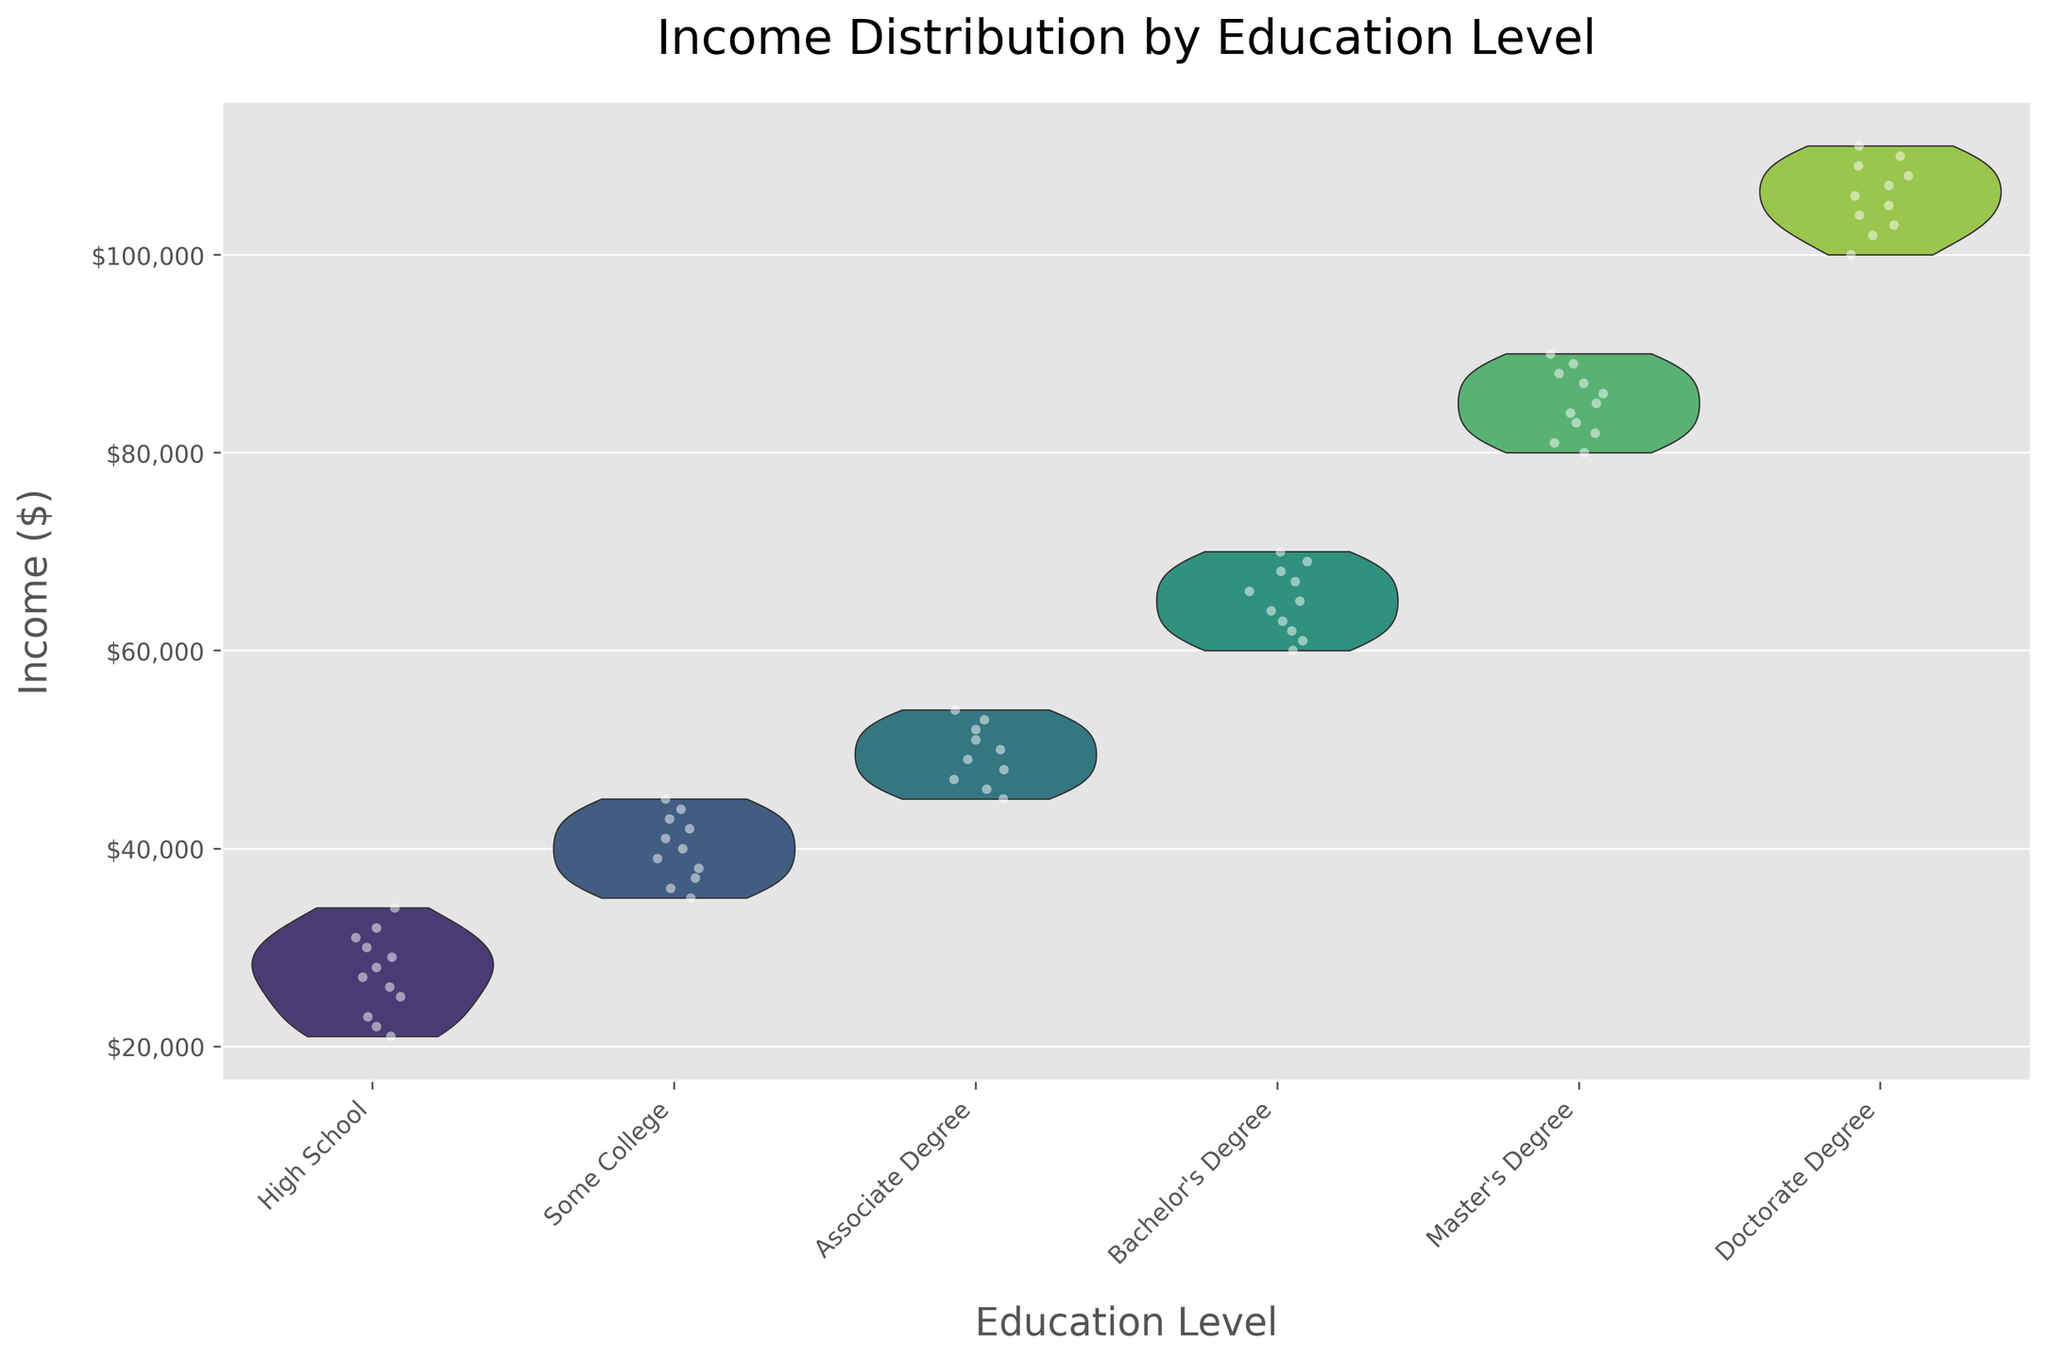What is the title of the figure? The title of the figure can be found at the top of the plot where it summarizes the content of the figure.
Answer: Income Distribution by Education Level What does the y-axis represent? The y-axis typically represents the variable being measured. In this plot, it shows the income levels in dollars, as indicated by the label on the y-axis.
Answer: Income ($) How are the data points displayed on the plot? The data points are jittered and displayed as white dots to prevent overlap, enhancing the visibility and dispersion representation across the education levels.
Answer: Jittered white points Which education level has the widest spread in income distribution? By observing the width of the violin plots, we can see which education level has the largest spread in income values.
Answer: Bachelor's Degree How does the median income compare between Associate Degree and Master's Degree holders? From the violin plot, observe the central line of density distribution for each education level to compare the median incomes of the two groups.
Answer: Median is higher for Master's Degree What color palette is used in the plot? The plot uses a specific color palette to distinguish between different education levels. Here, it's the 'viridis' palette which blends from purple to yellow.
Answer: Viridis Which education level shows the highest income outlier? By examining the topmost points and the density distribution in each violin, you can identify which level has the highest income outlier.
Answer: Doctorate Degree How is the data trend from High School to Doctorate Degree? By following the trend from High School to Doctorate Degree in the plot, one can observe how the median and spread of income change across educational levels.
Answer: Increasing income trend What is the approximate range of incomes for Bachelor's Degree holders? Observe the upper and lower bounds of the Bachelor’s Degree violin plot to approximate the range of incomes for this group.
Answer: $60,000 to $70,000 